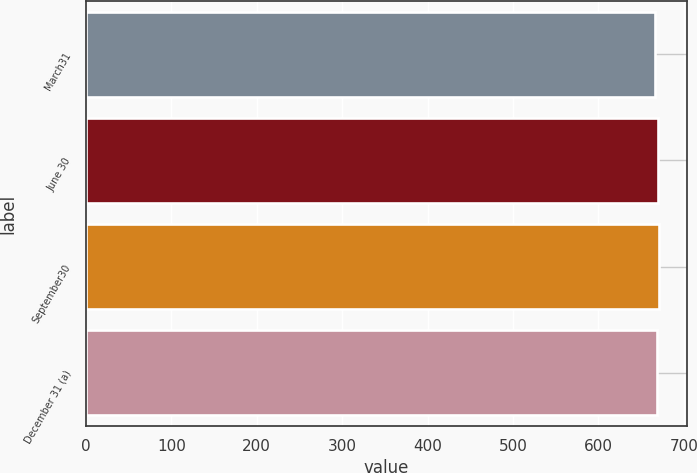Convert chart to OTSL. <chart><loc_0><loc_0><loc_500><loc_500><bar_chart><fcel>March31<fcel>June 30<fcel>September30<fcel>December 31 (a)<nl><fcel>666<fcel>670<fcel>670.4<fcel>668<nl></chart> 